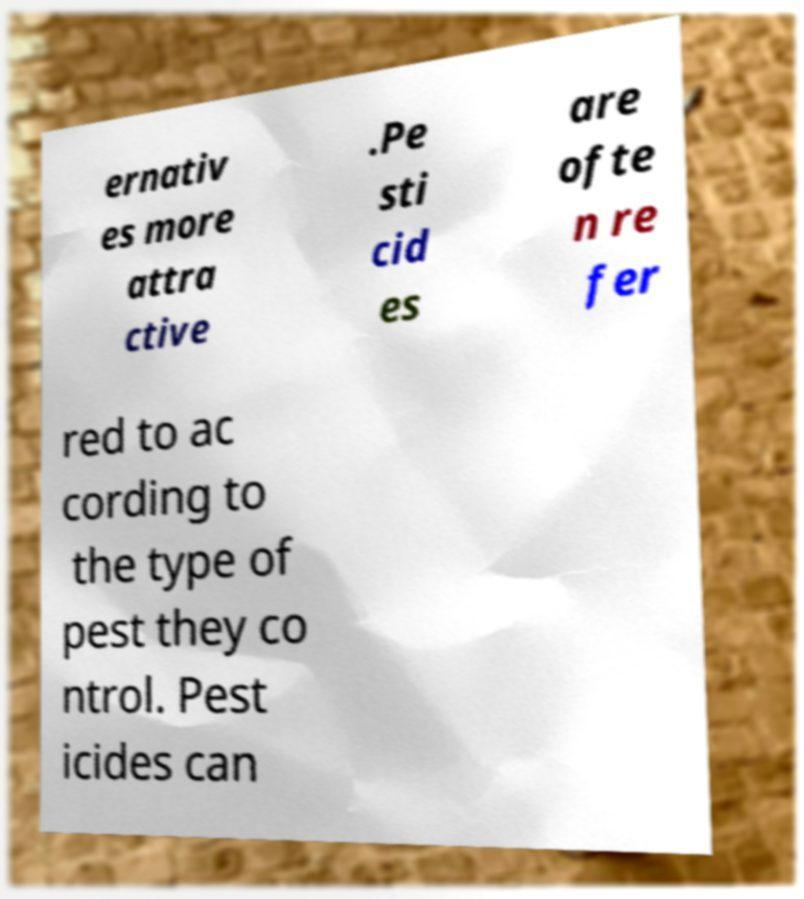Could you assist in decoding the text presented in this image and type it out clearly? ernativ es more attra ctive .Pe sti cid es are ofte n re fer red to ac cording to the type of pest they co ntrol. Pest icides can 